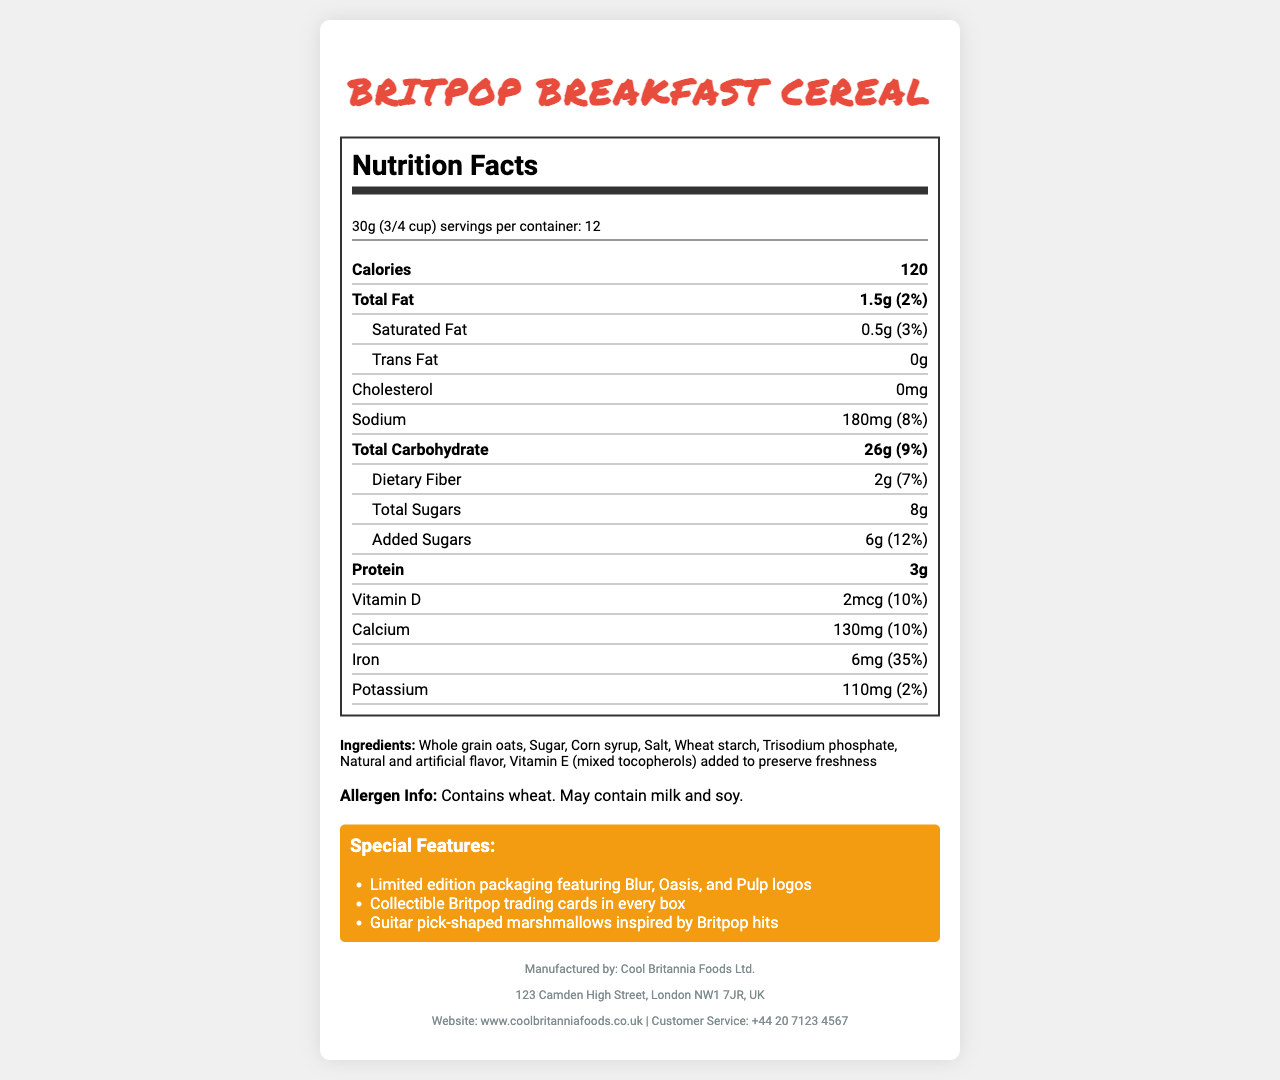what is the serving size? The serving size is mentioned at the top of the nutrition information as "30g (3/4 cup)".
Answer: 30g (3/4 cup) how many calories are in one serving? The number of calories per serving is listed as 120.
Answer: 120 what is the total fat content in one serving? The total fat content is shown as 1.5g.
Answer: 1.5g how much dietary fiber does one serving contain? The dietary fiber content per serving is listed as 2g.
Answer: 2g how much iron is in one serving? The iron content per serving is shown as 6mg.
Answer: 6mg what are the main ingredients in the cereal? The ingredients are listed in the ingredients section of the label.
Answer: Whole grain oats, Sugar, Corn syrup, Salt, Wheat starch, Trisodium phosphate, Natural and artificial flavor, Vitamin E (mixed tocopherols) added to preserve freshness how many servings are there in one container? The number of servings per container is listed as 12.
Answer: 12 does this cereal contain any allergens? The document states the cereal contains wheat and may contain milk and soy.
Answer: Yes which vitamin is included at 10% of the daily value? The nutrient list indicates that Vitamin D is included at 10% of the daily value.
Answer: Vitamin D which of the following is NOT a special feature of this cereal? A. Limited edition packaging featuring Blur, Oasis, and Pulp logos B. Collectible Britpop trading cards in every box C. Free concert tickets with every purchase The special features listed are: Limited edition packaging, collectible trading cards, and guitar pick-shaped marshmallows. Free concert tickets are not mentioned.
Answer: C which special feature is NOT related to the packaging? A. Limited edition packaging featuring Blur, Oasis, and Pulp logos B. Collectible Britpop trading cards in every box C. Guitar pick-shaped marshmallows The guitar pick-shaped marshmallows are a feature of the cereal itself, whereas the other two options are related to the packaging.
Answer: C is there any cholesterol in the cereal? The document states that the cholesterol content is 0mg.
Answer: No describe the special features mentioned in the document. The document's special features section highlights the branding and collectible items, emphasizing the unique Britpop theme.
Answer: The cereal features limited edition packaging with logos of iconic Britpop bands Blur, Oasis, and Pulp. Each box contains collectible Britpop trading cards, and the cereal pieces include guitar pick-shaped marshmallows inspired by Britpop hits. what is the total sugar content, including added sugars? The total sugars include 8g, with 6g of added sugars specifically mentioned.
Answer: 8g where is the manufacturer located? The manufacturer address is given in the document as 123 Camden High Street, London NW1 7JR, UK.
Answer: 123 Camden High Street, London NW1 7JR, UK how does the cereal preserve freshness? The document states that Vitamin E (mixed tocopherols) is added to preserve freshness, but it does not elaborate on the specific preservation process.
Answer: I don't know 